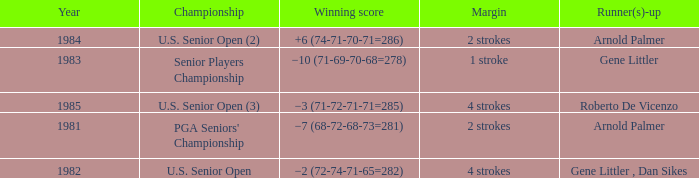What championship was in 1985? U.S. Senior Open (3). Parse the full table. {'header': ['Year', 'Championship', 'Winning score', 'Margin', 'Runner(s)-up'], 'rows': [['1984', 'U.S. Senior Open (2)', '+6 (74-71-70-71=286)', '2 strokes', 'Arnold Palmer'], ['1983', 'Senior Players Championship', '−10 (71-69-70-68=278)', '1 stroke', 'Gene Littler'], ['1985', 'U.S. Senior Open (3)', '−3 (71-72-71-71=285)', '4 strokes', 'Roberto De Vicenzo'], ['1981', "PGA Seniors' Championship", '−7 (68-72-68-73=281)', '2 strokes', 'Arnold Palmer'], ['1982', 'U.S. Senior Open', '−2 (72-74-71-65=282)', '4 strokes', 'Gene Littler , Dan Sikes']]} 